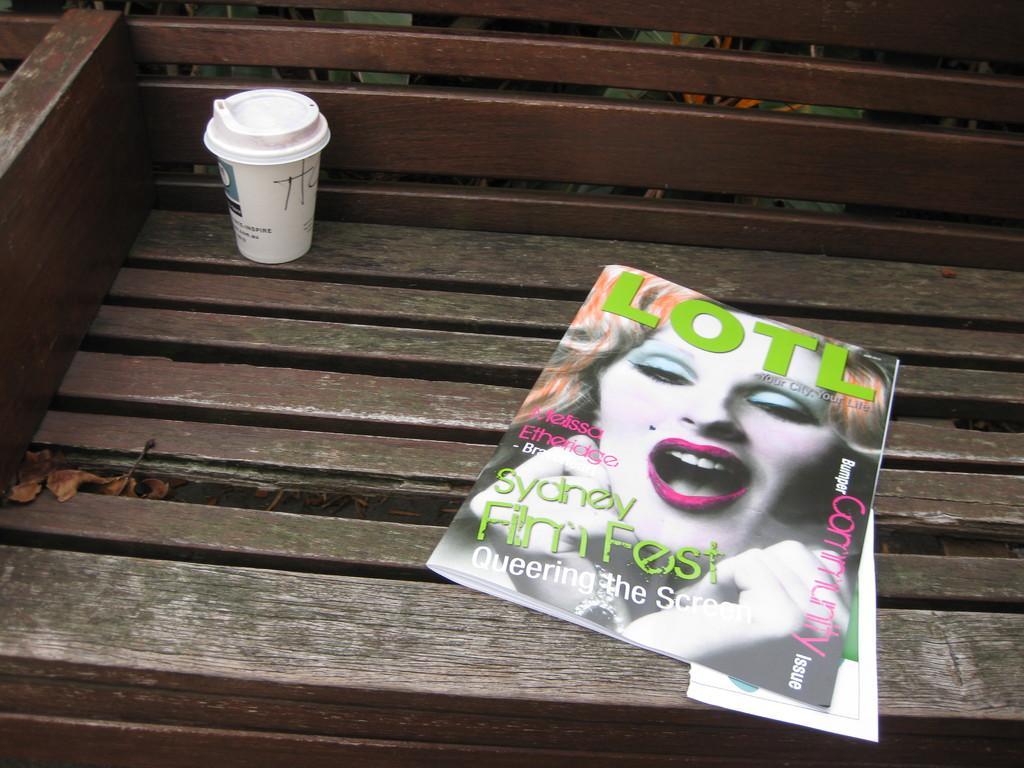What type of reading material is present in the image? There is a magazine in the image. What other item made of paper can be seen in the image? There is paper in the image. What type of container is visible in the image? There is a cup in the image. What is the color of the bench in the image? The bench is brown in color. What is the name of the daughter in the image? There is no daughter present in the image. What type of hope can be seen in the image? There is no hope visible in the image. 